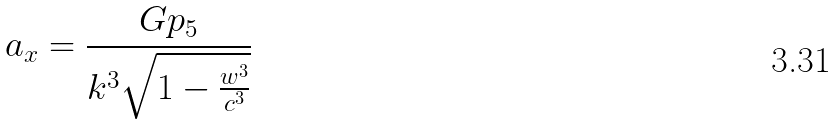<formula> <loc_0><loc_0><loc_500><loc_500>a _ { x } = \frac { G p _ { 5 } } { k ^ { 3 } \sqrt { 1 - \frac { w ^ { 3 } } { c ^ { 3 } } } }</formula> 